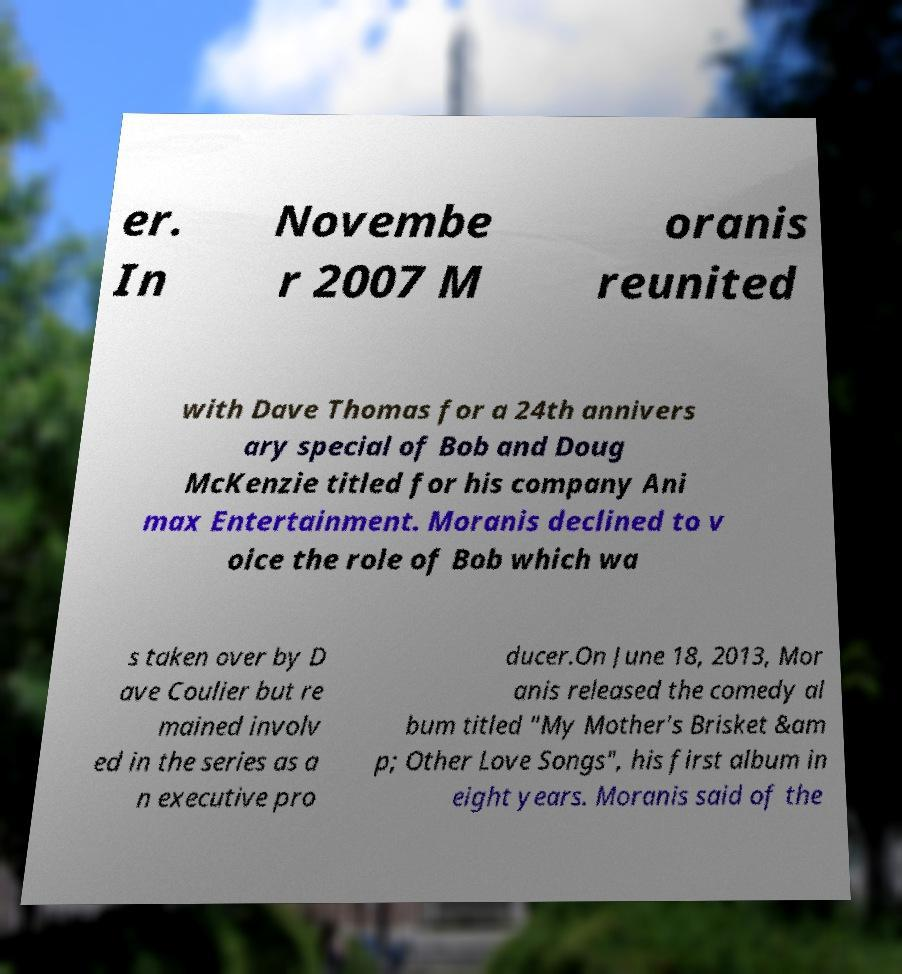There's text embedded in this image that I need extracted. Can you transcribe it verbatim? er. In Novembe r 2007 M oranis reunited with Dave Thomas for a 24th annivers ary special of Bob and Doug McKenzie titled for his company Ani max Entertainment. Moranis declined to v oice the role of Bob which wa s taken over by D ave Coulier but re mained involv ed in the series as a n executive pro ducer.On June 18, 2013, Mor anis released the comedy al bum titled "My Mother's Brisket &am p; Other Love Songs", his first album in eight years. Moranis said of the 